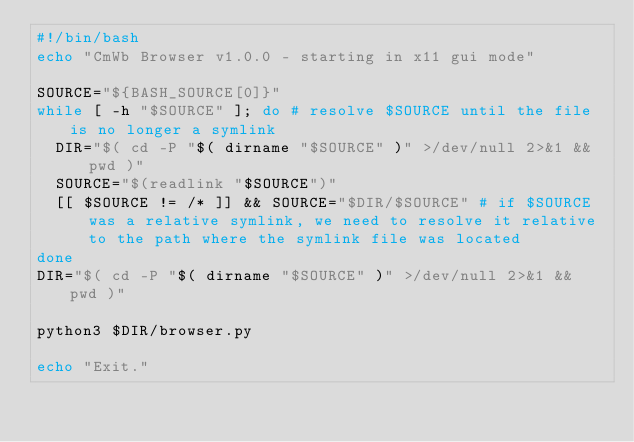Convert code to text. <code><loc_0><loc_0><loc_500><loc_500><_Bash_>#!/bin/bash
echo "CmWb Browser v1.0.0 - starting in x11 gui mode"

SOURCE="${BASH_SOURCE[0]}"
while [ -h "$SOURCE" ]; do # resolve $SOURCE until the file is no longer a symlink
  DIR="$( cd -P "$( dirname "$SOURCE" )" >/dev/null 2>&1 && pwd )"
  SOURCE="$(readlink "$SOURCE")"
  [[ $SOURCE != /* ]] && SOURCE="$DIR/$SOURCE" # if $SOURCE was a relative symlink, we need to resolve it relative to the path where the symlink file was located
done
DIR="$( cd -P "$( dirname "$SOURCE" )" >/dev/null 2>&1 && pwd )"

python3 $DIR/browser.py

echo "Exit."
</code> 